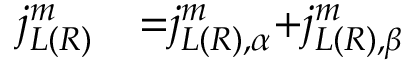<formula> <loc_0><loc_0><loc_500><loc_500>\begin{array} { l l } { { j } _ { L ( R ) } ^ { m } } & { { = } { j } _ { { L ( R ) , } \alpha } ^ { m } { + } { j } _ { { L ( R ) , } \beta } ^ { m } } \end{array}</formula> 